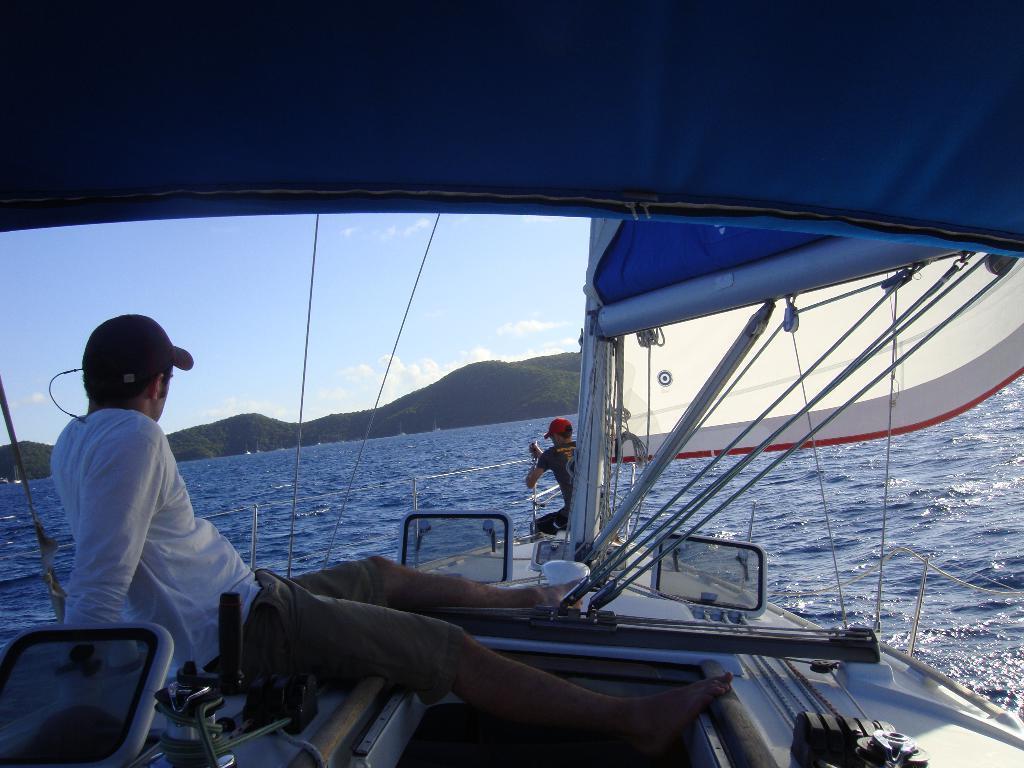Please provide a concise description of this image. This image is clicked in an ocean. In the front, there is a boat in white color. To the top, there is blue color cloth. There are two men in this boat. To the left, the man is wearing white shirt. At the bottom, there is water. In the background, there are mountains along with sky. 